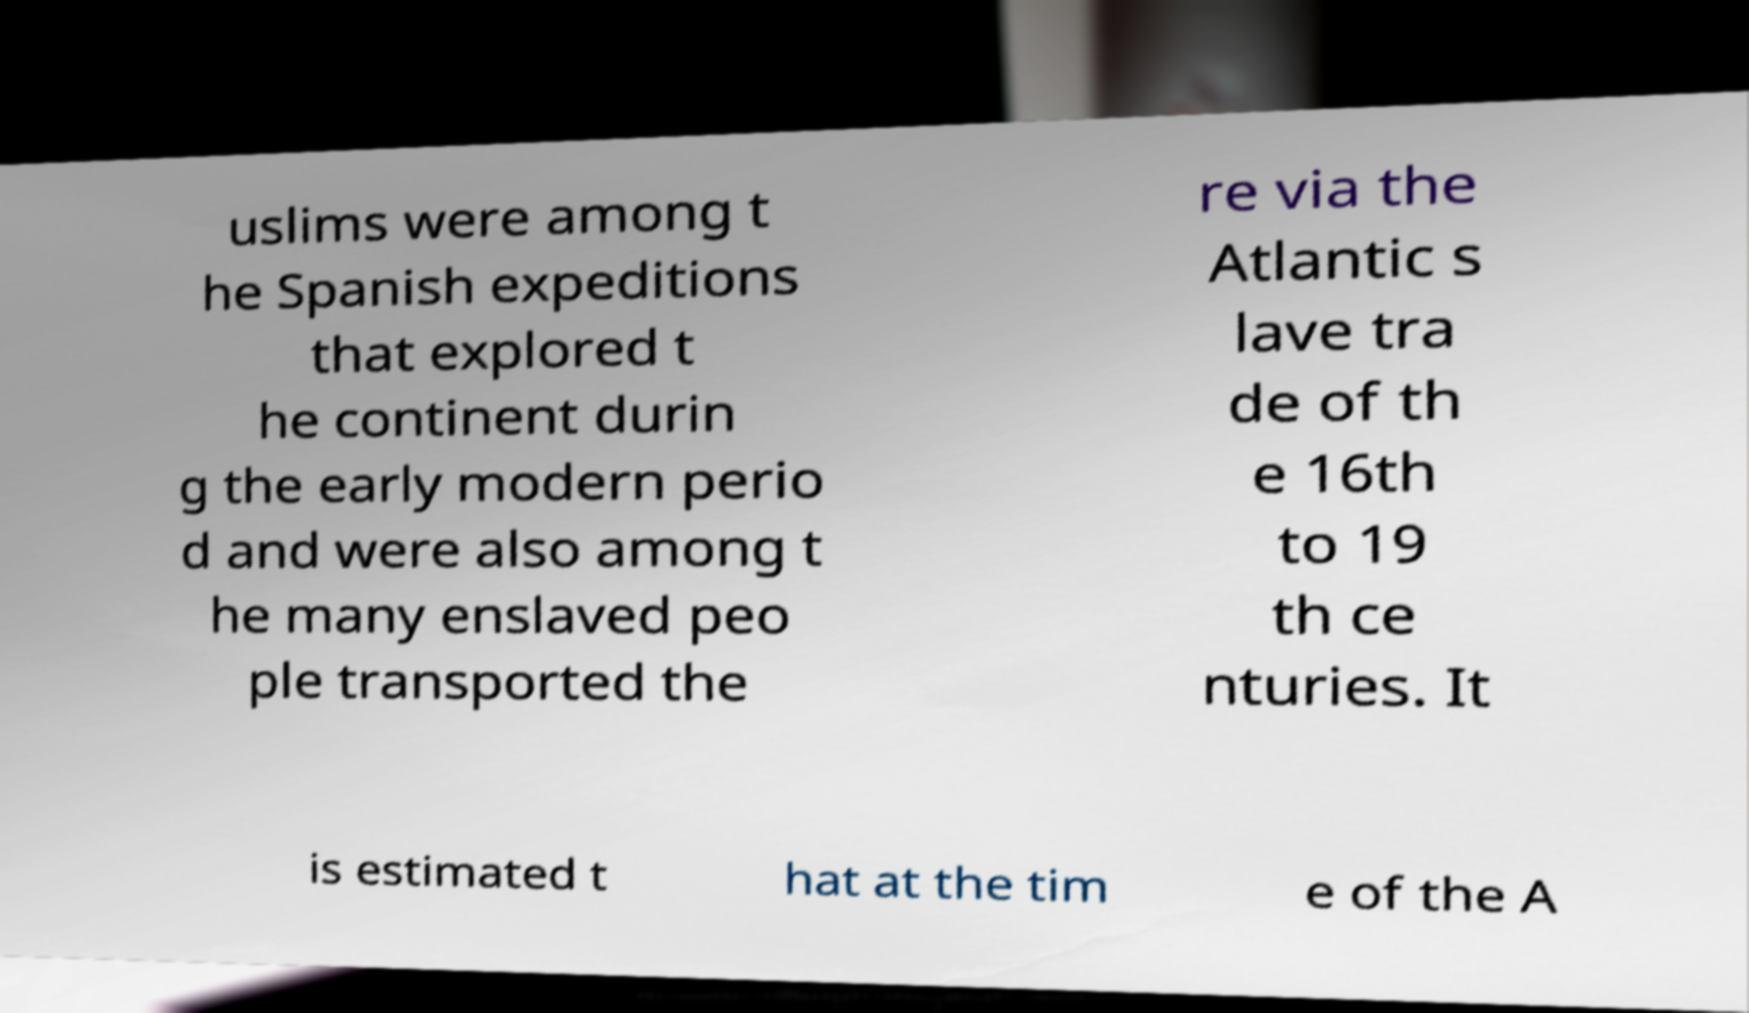For documentation purposes, I need the text within this image transcribed. Could you provide that? uslims were among t he Spanish expeditions that explored t he continent durin g the early modern perio d and were also among t he many enslaved peo ple transported the re via the Atlantic s lave tra de of th e 16th to 19 th ce nturies. It is estimated t hat at the tim e of the A 